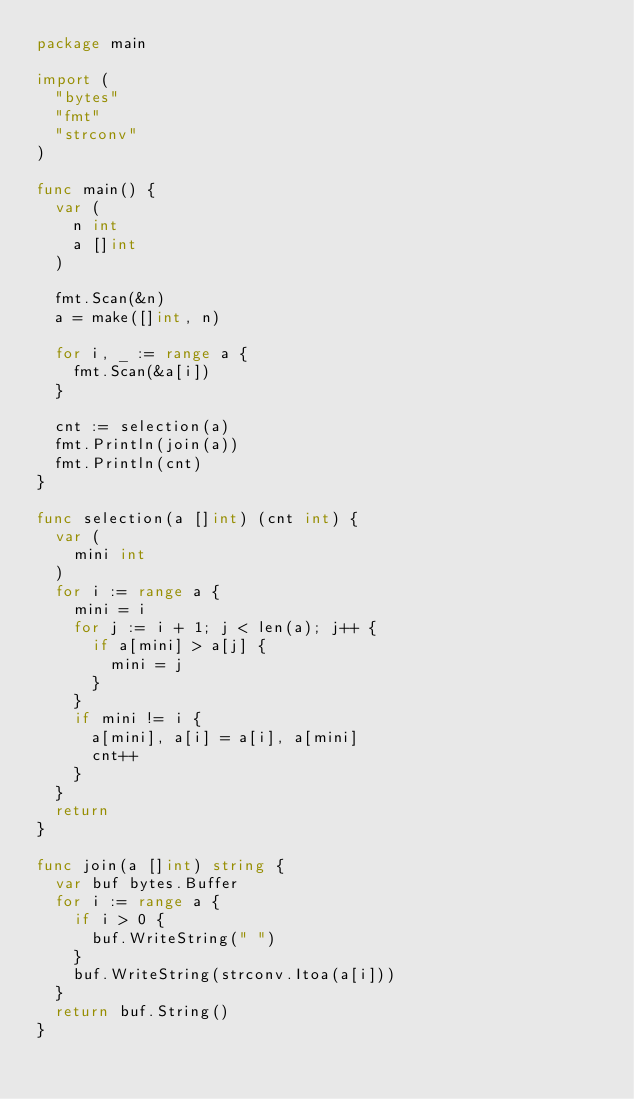Convert code to text. <code><loc_0><loc_0><loc_500><loc_500><_Go_>package main

import (
	"bytes"
	"fmt"
	"strconv"
)

func main() {
	var (
		n int
		a []int
	)

	fmt.Scan(&n)
	a = make([]int, n)

	for i, _ := range a {
		fmt.Scan(&a[i])
	}

	cnt := selection(a)
	fmt.Println(join(a))
	fmt.Println(cnt)
}

func selection(a []int) (cnt int) {
	var (
		mini int
	)
	for i := range a {
		mini = i
		for j := i + 1; j < len(a); j++ {
			if a[mini] > a[j] {
				mini = j
			}
		}
		if mini != i {
			a[mini], a[i] = a[i], a[mini]
			cnt++
		}
	}
	return
}

func join(a []int) string {
	var buf bytes.Buffer
	for i := range a {
		if i > 0 {
			buf.WriteString(" ")
		}
		buf.WriteString(strconv.Itoa(a[i]))
	}
	return buf.String()
}

</code> 